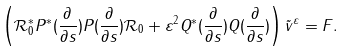Convert formula to latex. <formula><loc_0><loc_0><loc_500><loc_500>\left ( \mathcal { R } _ { 0 } ^ { * } P ^ { * } ( \frac { \partial } { \partial s } ) P ( \frac { \partial } { \partial s } ) \mathcal { R } _ { 0 } + \varepsilon ^ { 2 } Q ^ { * } ( \frac { \partial } { \partial s } ) Q ( \frac { \partial } { \partial s } ) \right ) \tilde { v } ^ { \varepsilon } = F .</formula> 